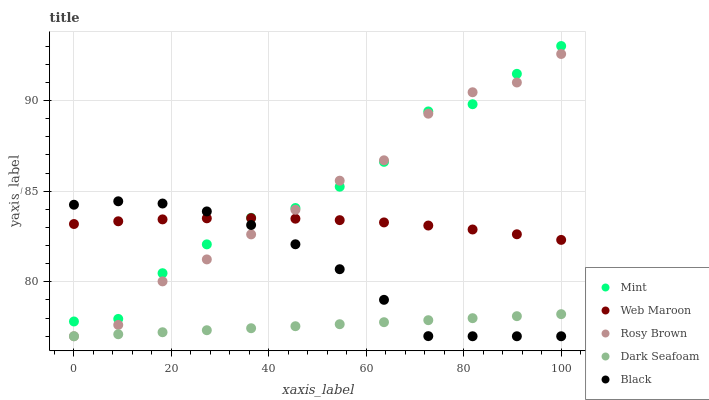Does Dark Seafoam have the minimum area under the curve?
Answer yes or no. Yes. Does Mint have the maximum area under the curve?
Answer yes or no. Yes. Does Rosy Brown have the minimum area under the curve?
Answer yes or no. No. Does Rosy Brown have the maximum area under the curve?
Answer yes or no. No. Is Dark Seafoam the smoothest?
Answer yes or no. Yes. Is Mint the roughest?
Answer yes or no. Yes. Is Rosy Brown the smoothest?
Answer yes or no. No. Is Rosy Brown the roughest?
Answer yes or no. No. Does Dark Seafoam have the lowest value?
Answer yes or no. Yes. Does Mint have the lowest value?
Answer yes or no. No. Does Mint have the highest value?
Answer yes or no. Yes. Does Rosy Brown have the highest value?
Answer yes or no. No. Is Dark Seafoam less than Mint?
Answer yes or no. Yes. Is Web Maroon greater than Dark Seafoam?
Answer yes or no. Yes. Does Rosy Brown intersect Black?
Answer yes or no. Yes. Is Rosy Brown less than Black?
Answer yes or no. No. Is Rosy Brown greater than Black?
Answer yes or no. No. Does Dark Seafoam intersect Mint?
Answer yes or no. No. 